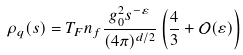Convert formula to latex. <formula><loc_0><loc_0><loc_500><loc_500>\rho _ { q } ( s ) = T _ { F } n _ { f } \frac { g _ { 0 } ^ { 2 } s ^ { - \varepsilon } } { ( 4 \pi ) ^ { d / 2 } } \left ( \frac { 4 } { 3 } + \mathcal { O } ( \varepsilon ) \right )</formula> 